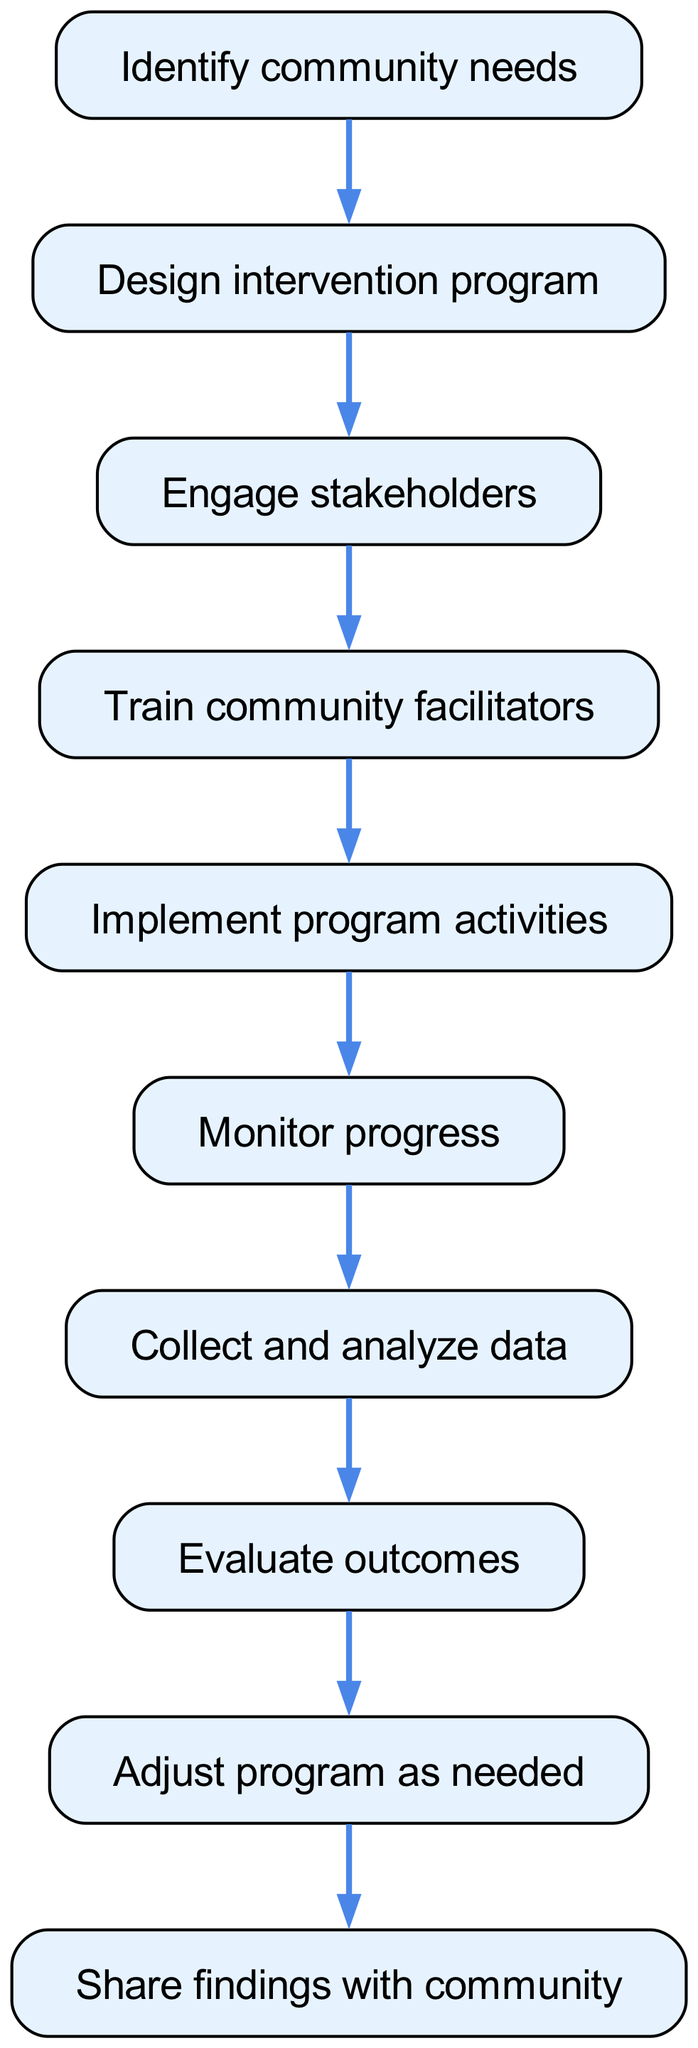What is the first step in the community-based intervention program? The diagram shows that the first step is "Identify community needs," as it is the initial element listed.
Answer: Identify community needs How many nodes are present in the diagram? By counting each distinct step from "Identify community needs" to "Share findings with community," we find that there are a total of ten nodes.
Answer: 10 What activity follows “Train community facilitators”? According to the flow, the next activity that follows “Train community facilitators” is "Implement program activities."
Answer: Implement program activities Which step involves evaluating the results of the program? The node labeled "Evaluate outcomes" specifically addresses the evaluation of program results, making it the step that focuses on this aspect.
Answer: Evaluate outcomes What is the relationship between "Collect and analyze data" and "Evaluate outcomes"? "Collect and analyze data" is a precursor to "Evaluate outcomes," indicating that data collection must occur before the evaluation of outcomes can take place.
Answer: Preceding step If the program requires adjustments, which step would come next? After "Evaluate outcomes," the flow directs to the step "Adjust program as needed," indicating that any necessary adjustments occur thereafter.
Answer: Adjust program as needed Which step directly communicates the findings back to the community? The final step in the diagram is "Share findings with community," explicitly listing it as the action to communicate results back to the community.
Answer: Share findings with community What is the fourth step in the intervention program? By tracing through the steps, the fourth operation is "Train community facilitators," placed sequentially as the fourth node in the flow.
Answer: Train community facilitators How does stakeholder engagement relate to intervention design? Stakeholder engagement occurs after the design of the intervention program, indicating that the design must be completed before stakeholders can be brought into the process.
Answer: Follows intervention design 